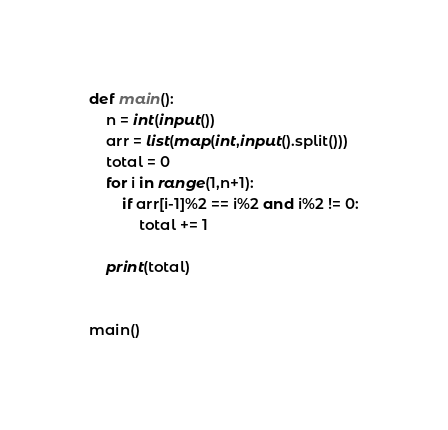Convert code to text. <code><loc_0><loc_0><loc_500><loc_500><_Python_>def main():
    n = int(input())
    arr = list(map(int,input().split()))
    total = 0
    for i in range(1,n+1):
        if arr[i-1]%2 == i%2 and i%2 != 0:
            total += 1

    print(total)
    

main()
</code> 